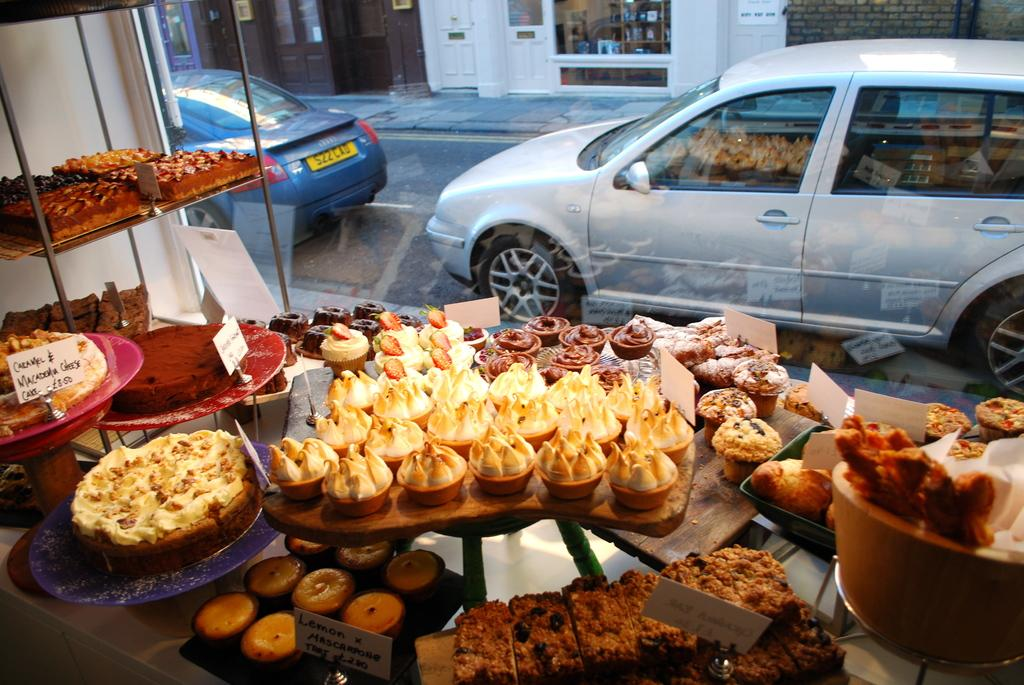What can be found on the racks in the image? There are food items on the racks in the image. What type of structures are visible in the image? Boards, buildings, and a wall are visible in the image. What is in front of the image? Vehicles, a door, and glass windows are in front of the image. Can you tell me how many cabbages are on the racks in the image? There is no mention of cabbages in the image; the food items on the racks are not specified. Is there a horse visible in the image? No, there is no horse present in the image. 